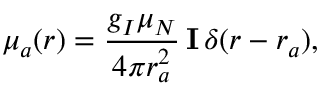<formula> <loc_0><loc_0><loc_500><loc_500>\boldsymbol \mu _ { a } ( r ) = \frac { g _ { I } \mu _ { N } } { 4 \pi r _ { a } ^ { 2 } } \, I \, \delta ( r - r _ { a } ) ,</formula> 